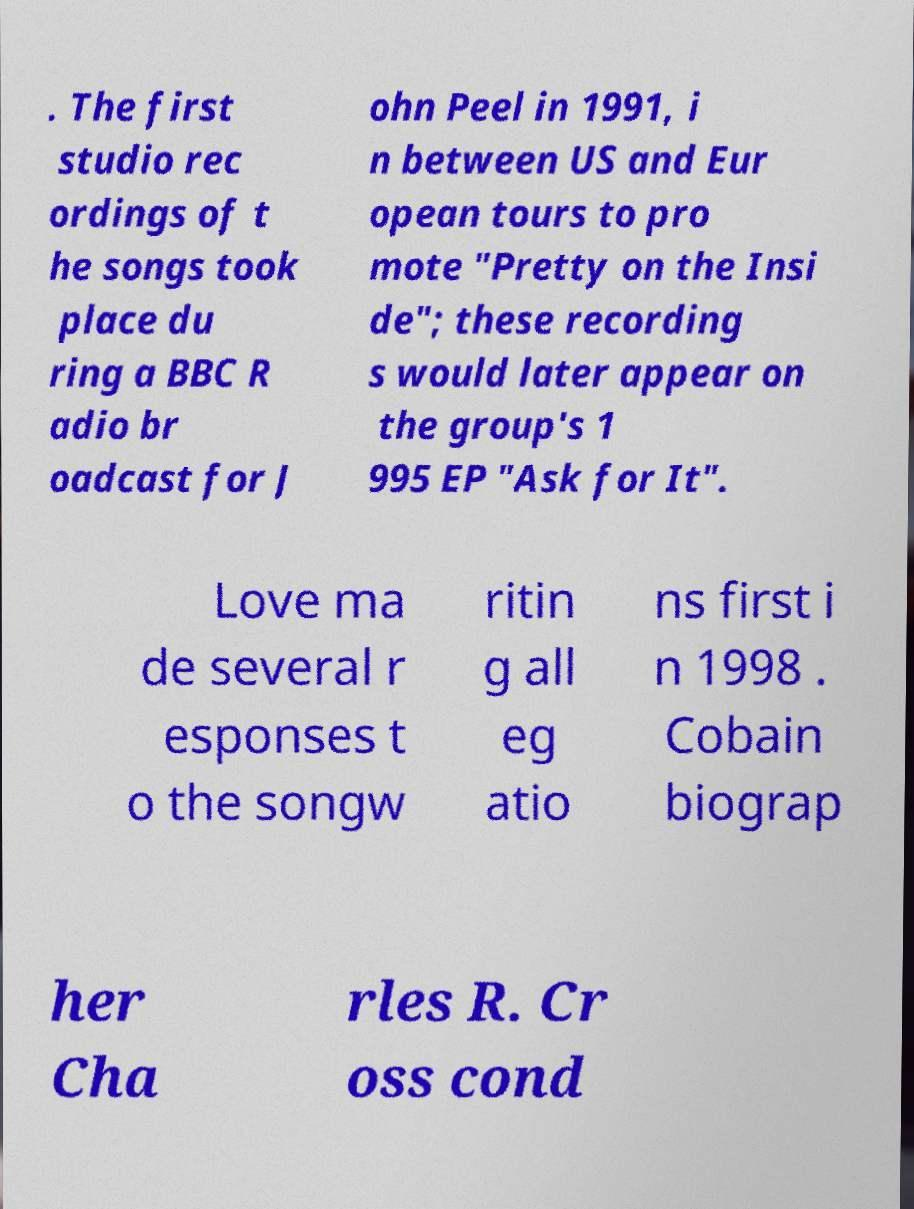Please identify and transcribe the text found in this image. . The first studio rec ordings of t he songs took place du ring a BBC R adio br oadcast for J ohn Peel in 1991, i n between US and Eur opean tours to pro mote "Pretty on the Insi de"; these recording s would later appear on the group's 1 995 EP "Ask for It". Love ma de several r esponses t o the songw ritin g all eg atio ns first i n 1998 . Cobain biograp her Cha rles R. Cr oss cond 